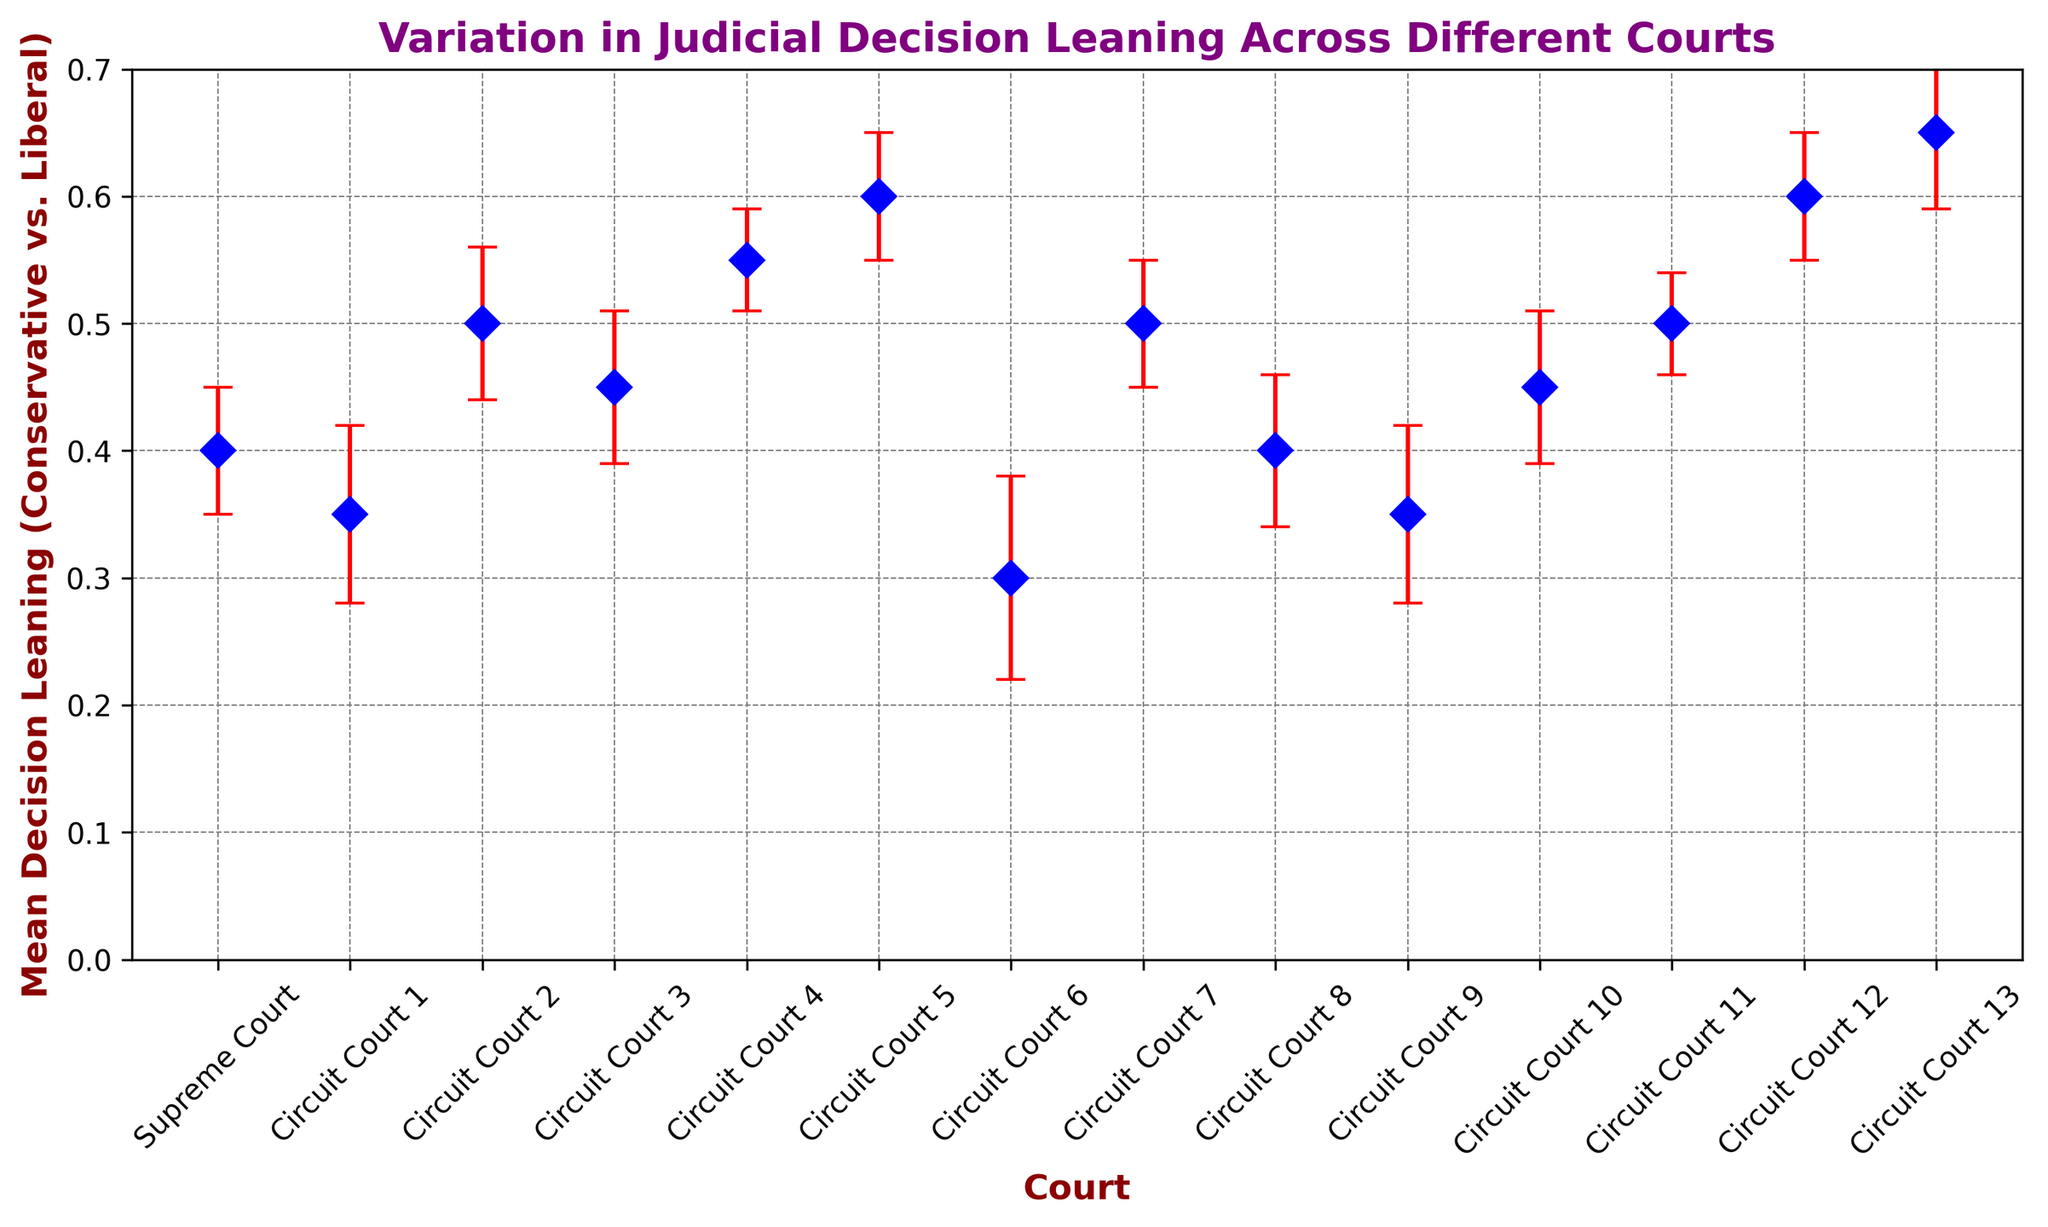Which court has the highest mean decision leaning? The court with the highest mean decision leaning is identified by the tallest data point on the y-axis. Circuit Court 13 has the highest mean decision leaning at 0.65.
Answer: Circuit Court 13 Which courts have the same mean decision leaning? Identifying the courts with the same mean decision leaning involves looking for data points that are at the same height on the y-axis. Circuit Court 2, Circuit Court 7, Circuit Court 11 each have a mean decision leaning of 0.50. Circuit Court 9 and Circuit Court 1 both have a mean decision leaning of 0.35.
Answer: Circuit Court 2, Circuit Court 7, Circuit Court 11; Circuit Court 9, Circuit Court 1 What is the range of mean decision leaning across all courts? The range is calculated by subtracting the minimum mean decision leaning from the maximum mean decision leaning. The maximum is 0.65 (Circuit Court 13), and the minimum is 0.30 (Circuit Court 6), so the range is 0.65 - 0.30 = 0.35.
Answer: 0.35 Which court has the highest standard error? The court with the highest standard error is identified by the largest error bar extending above and below its mean point. Circuit Court 6 has the highest standard error at 0.08.
Answer: Circuit Court 6 Which courts fall within the 0.4 to 0.5 mean decision leaning range? Courts within this range are identified by inspecting all data points that fall between 0.4 and 0.5 on the y-axis. Courts falling in this range are Supreme Court (0.4), Circuit Court 3 (0.45), Circuit Court 8 (0.4), Circuit Court 10 (0.45).
Answer: Supreme Court, Circuit Court 3, Circuit Court 8, Circuit Court 10 What is the average mean decision leaning of all Circuit Courts? First, total the mean decision leanings of all Circuit Courts and then divide by the number of Circuit Courts (13). The sum of mean decision leanings is 5.85. The average mean decision leaning is 5.85 / 13 = 0.45.
Answer: 0.45 Which court has an overlapping error bar with the Supreme Court? Identifying courts with overlapping error bars involves looking for courts where the error bars intersect. Circuit Courts 1, 8 have overlapping error bars with the Supreme Court because their error bars fall within the decision leaning interval of the Supreme Court (0.35-0.45).
Answer: Circuit Court 1, Circuit Court 8 